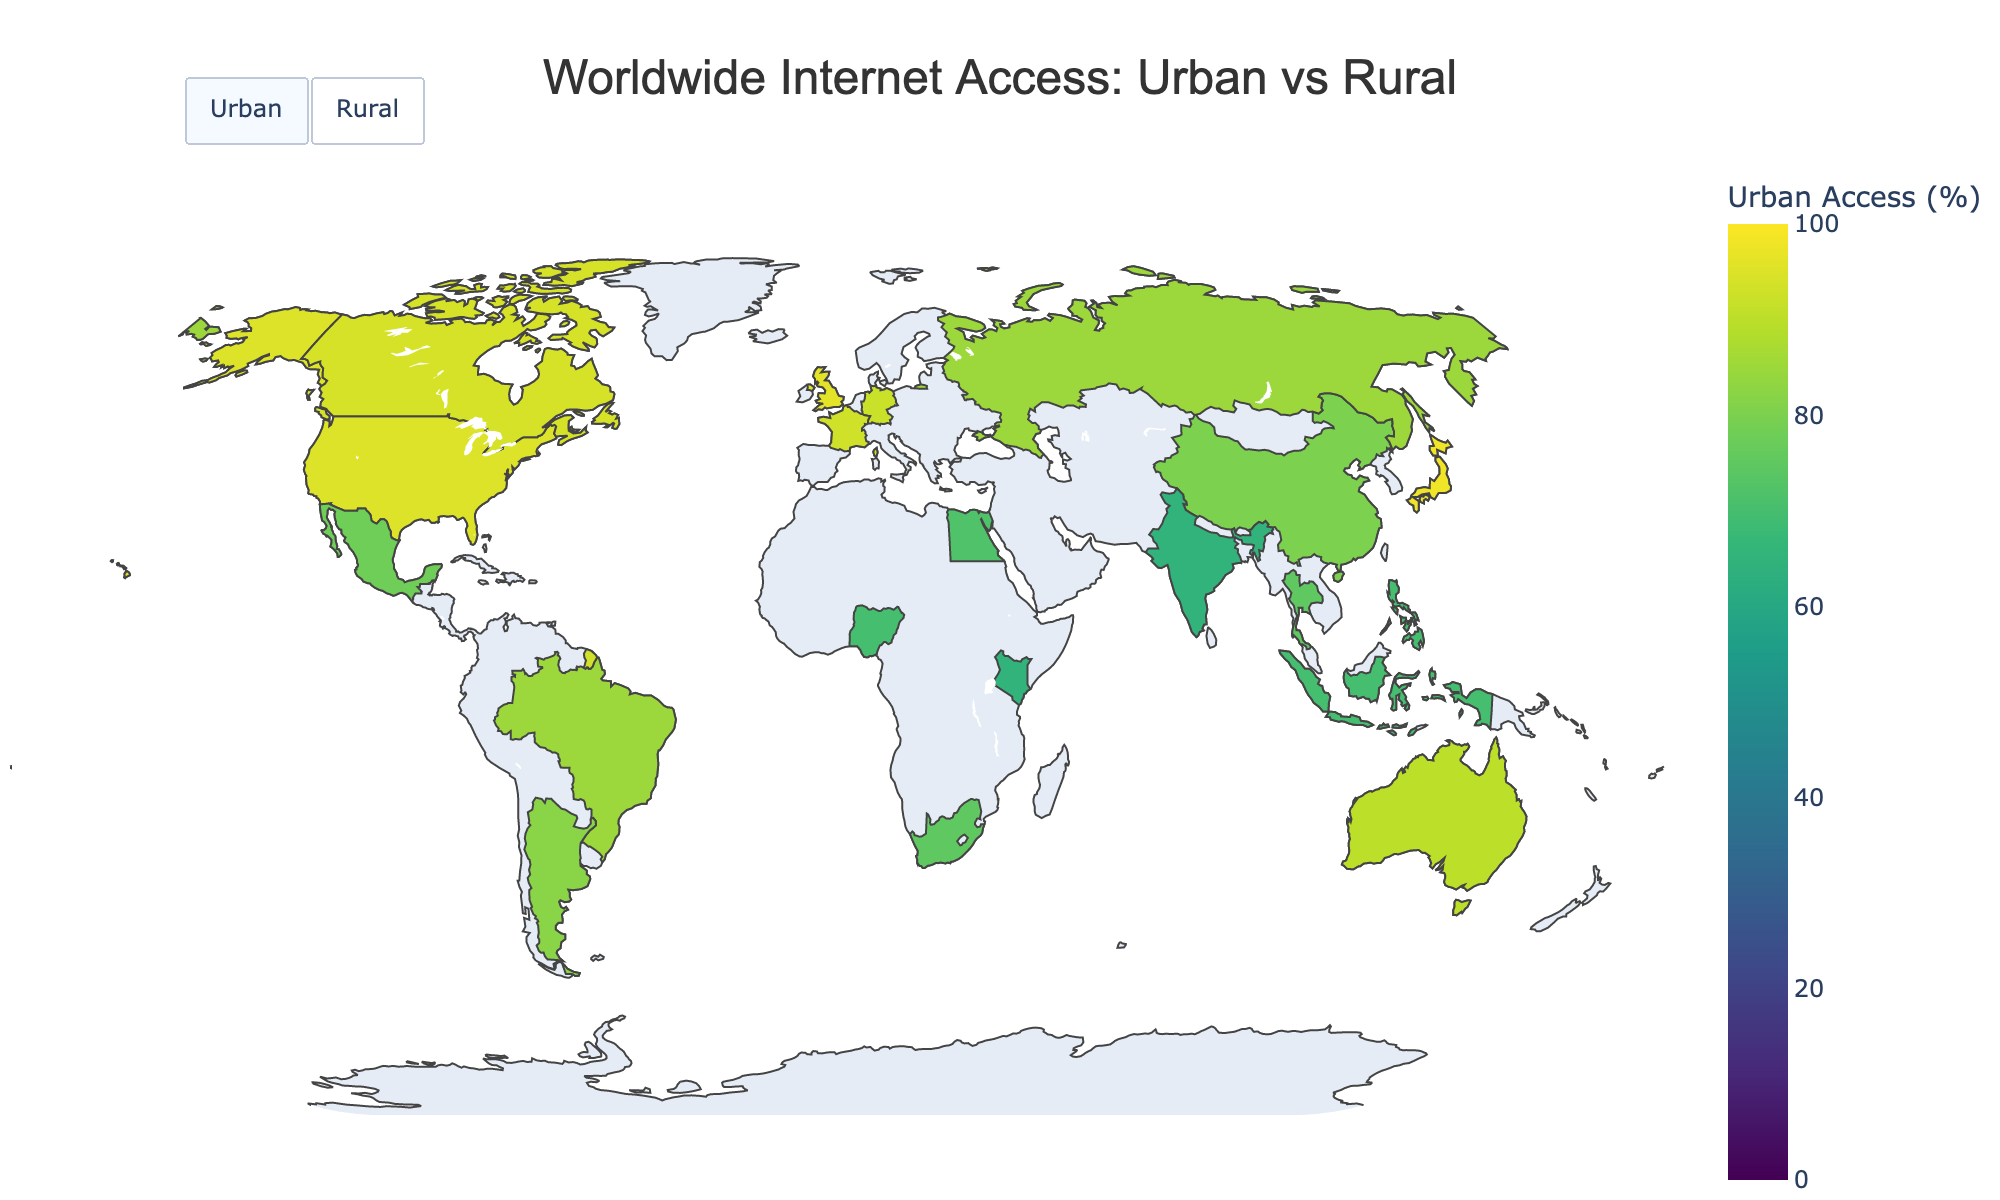What's the difference in internet access rates between urban and rural areas in the United States? The plot shows the internet access rates for both urban and rural areas in the United States. We subtract the rural internet access rate from the urban internet access rate: 95% - 82% = 13%
Answer: 13% Which country has the highest rural internet access rate? By examining the rural internet access rates in the plot, the country with the highest rate is the United Kingdom with a 90% access rate
Answer: United Kingdom What is the average urban internet access rate across all countries? To find the average urban internet access rate, add the urban rates for all countries and divide by the number of countries: (95 + 80 + 65 + 85 + 70 + 92 + 90 + 98 + 75 + 78 + 72 + 85 + 70 + 93 + 65 + 94 + 82 + 75 + 96 + 70) / 20 = 81.1%
Answer: 81.1% What are the urban and rural internet access rates in India? The plot indicates that India has an urban internet access rate of 65% and a rural access rate of 25%
Answer: Urban: 65%, Rural: 25% Which country has the largest gap between urban and rural internet access rates? To identify the largest gap, calculate the difference for each country and find the maximum: United States (13%), China (25%), India (40%), Brazil (25%), Nigeria (40%), Germany (4%), Australia (15%), Japan (13%), South Africa (35%), Mexico (33%), Egypt (37%), Russia (20%), Indonesia (30%), France (6%), Kenya (40%), Canada (9%), Argentina (22%), Thailand (25%), United Kingdom (6%), Philippines (35%)
Answer: Nigeria, India, and Kenya (all 40%) Are there any countries where the rural internet access rate is above 80%? Examine the rural internet access rates in the plot to see if any exceed 80%. The United Kingdom has a rural internet access rate of 90%
Answer: Yes, the United Kingdom What title is displayed for the plot when focusing on urban internet access? By looking at the plot, the title changes based on the selection. When focusing on urban internet access, it shows: "Urban Internet Access Rates"
Answer: Urban Internet Access Rates How does the rural internet access rate in China compare to that in Brazil? Compare the rural internet access rates shown in the plot: China has a 55% rate while Brazil has a 60% rate, making Brazil's rate higher
Answer: Brazil has a higher rate Which countries have both urban and rural internet access rates above 80%? Checking both urban and rural rates: Germany (92% urban, 88% rural), Japan (98% urban, 85% rural), Canada (94% urban, 85% rural), and United Kingdom (96% urban, 90% rural)
Answer: Germany, Japan, Canada, United Kingdom 